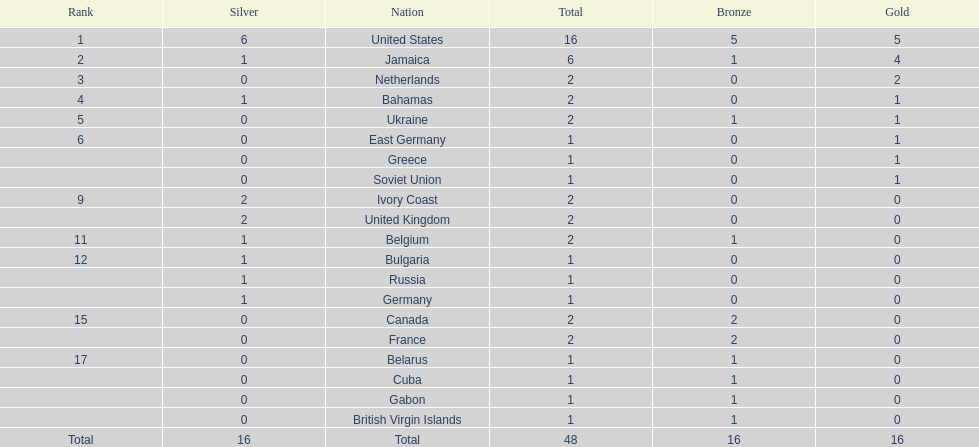Give me the full table as a dictionary. {'header': ['Rank', 'Silver', 'Nation', 'Total', 'Bronze', 'Gold'], 'rows': [['1', '6', 'United States', '16', '5', '5'], ['2', '1', 'Jamaica', '6', '1', '4'], ['3', '0', 'Netherlands', '2', '0', '2'], ['4', '1', 'Bahamas', '2', '0', '1'], ['5', '0', 'Ukraine', '2', '1', '1'], ['6', '0', 'East Germany', '1', '0', '1'], ['', '0', 'Greece', '1', '0', '1'], ['', '0', 'Soviet Union', '1', '0', '1'], ['9', '2', 'Ivory Coast', '2', '0', '0'], ['', '2', 'United Kingdom', '2', '0', '0'], ['11', '1', 'Belgium', '2', '1', '0'], ['12', '1', 'Bulgaria', '1', '0', '0'], ['', '1', 'Russia', '1', '0', '0'], ['', '1', 'Germany', '1', '0', '0'], ['15', '0', 'Canada', '2', '2', '0'], ['', '0', 'France', '2', '2', '0'], ['17', '0', 'Belarus', '1', '1', '0'], ['', '0', 'Cuba', '1', '1', '0'], ['', '0', 'Gabon', '1', '1', '0'], ['', '0', 'British Virgin Islands', '1', '1', '0'], ['Total', '16', 'Total', '48', '16', '16']]} How many gold medals did the us and jamaica win combined? 9. 